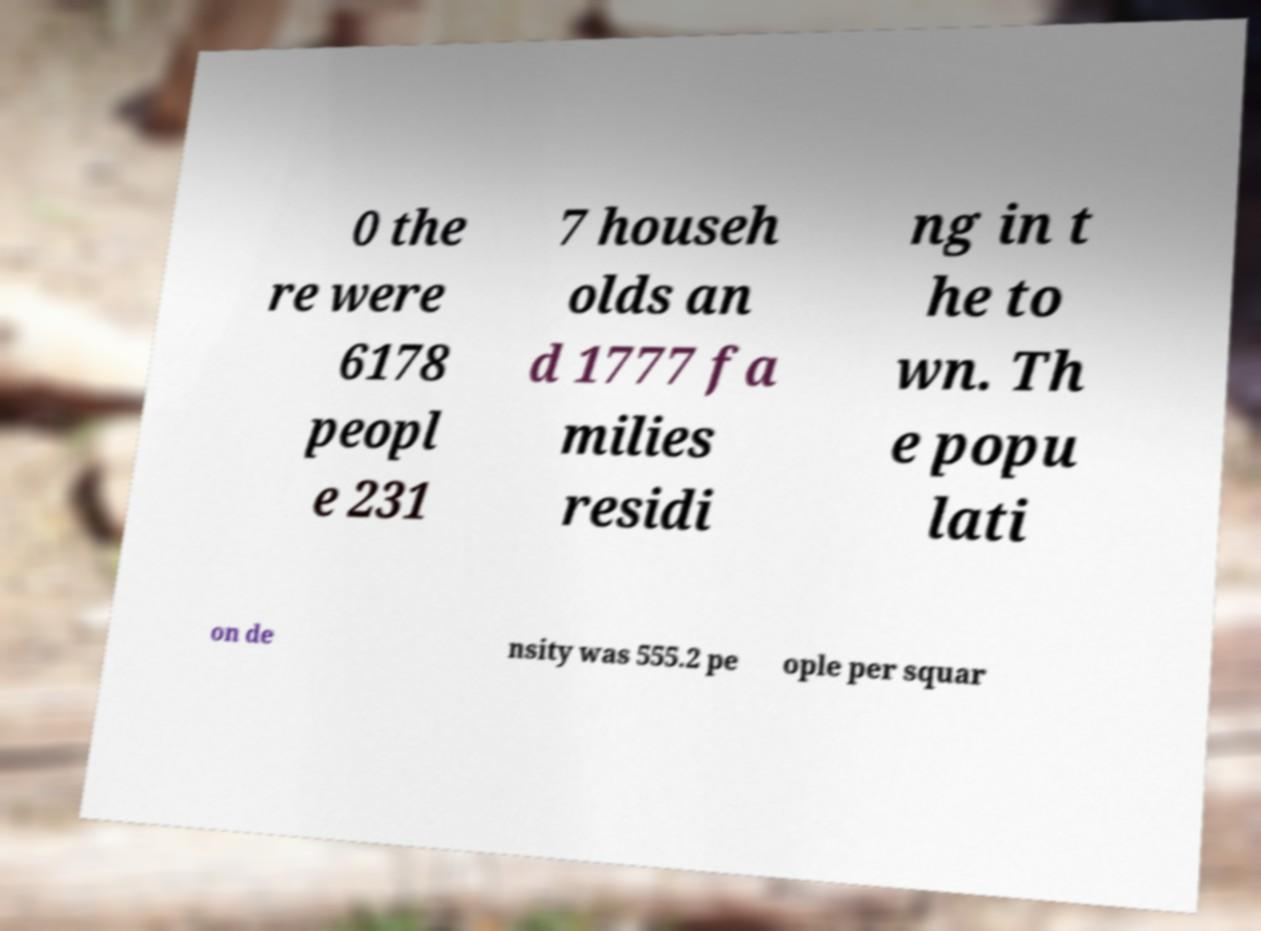Can you read and provide the text displayed in the image?This photo seems to have some interesting text. Can you extract and type it out for me? 0 the re were 6178 peopl e 231 7 househ olds an d 1777 fa milies residi ng in t he to wn. Th e popu lati on de nsity was 555.2 pe ople per squar 